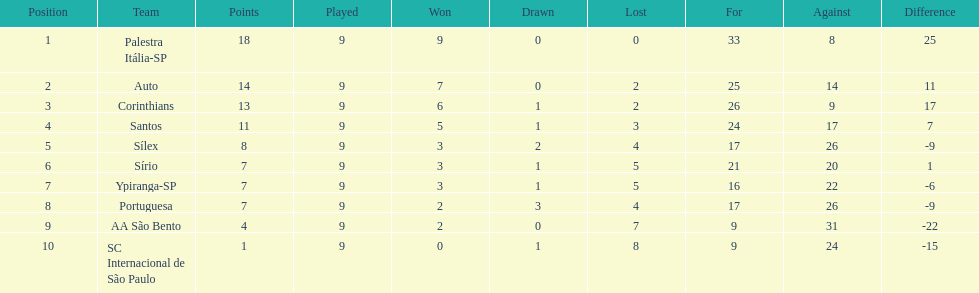What are all the teams? Palestra Itália-SP, Auto, Corinthians, Santos, Sílex, Sírio, Ypiranga-SP, Portuguesa, AA São Bento, SC Internacional de São Paulo. How many times did each team lose? 0, 2, 2, 3, 4, 5, 5, 4, 7, 8. And which team never lost? Palestra Itália-SP. 